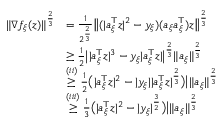<formula> <loc_0><loc_0><loc_500><loc_500>\begin{array} { r l } { \| \nabla f _ { \xi } ( z ) \| ^ { \frac { 2 } { 3 } } } & { = \frac { 1 } { 2 ^ { \frac { 2 } { 3 } } } \left \| ( | a _ { \xi } ^ { \top } z | ^ { 2 } - y _ { \xi } ) ( a _ { \xi } a _ { \xi } ^ { \top } ) z \right \| ^ { \frac { 2 } { 3 } } } \\ & { \geq \frac { 1 } { 2 } \left | | a _ { \xi } ^ { \top } z | ^ { 3 } - y _ { \xi } | a _ { \xi } ^ { \top } z | \right | ^ { \frac { 2 } { 3 } } \| a _ { \xi } \| ^ { \frac { 2 } { 3 } } } \\ & { \overset { ( i i ) } { \geq } \frac { 1 } { 2 } \left ( | a _ { \xi } ^ { \top } z | ^ { 2 } - | y _ { \xi } | | a _ { \xi } ^ { \top } z | ^ { \frac { 2 } { 3 } } \right ) \left | \| a _ { \xi } \| ^ { \frac { 2 } { 3 } } } \\ & { \overset { ( i i i ) } { \geq } \frac { 1 } { 3 } \left ( | a _ { \xi } ^ { \top } z | ^ { 2 } - | y _ { \xi } | ^ { \frac { 3 } { 2 } } \right ) \right | \| a _ { \xi } \| ^ { \frac { 2 } { 3 } } } \end{array}</formula> 